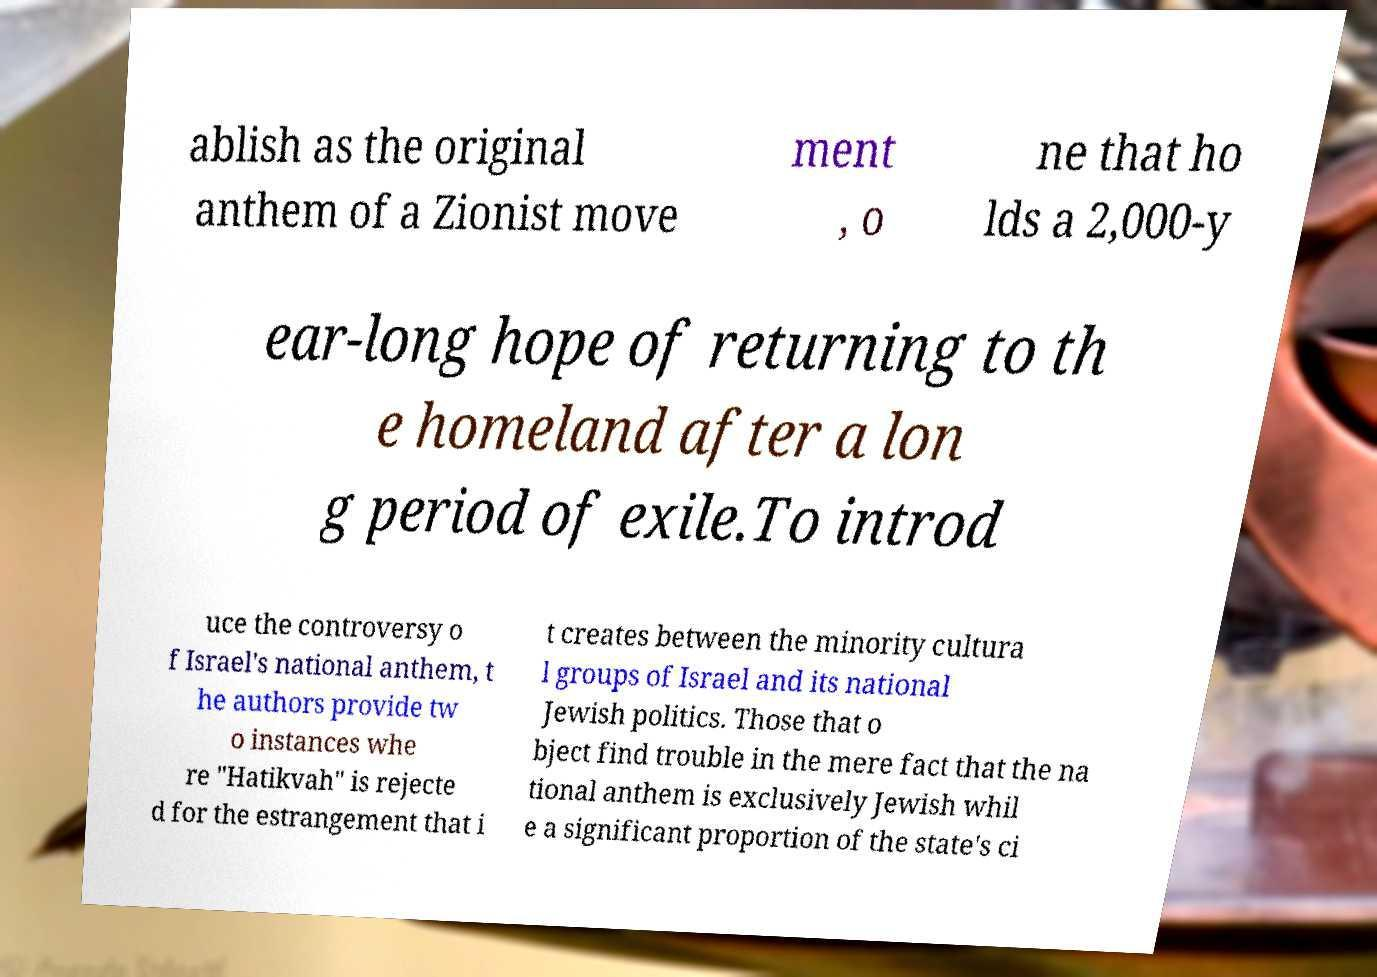What messages or text are displayed in this image? I need them in a readable, typed format. ablish as the original anthem of a Zionist move ment , o ne that ho lds a 2,000-y ear-long hope of returning to th e homeland after a lon g period of exile.To introd uce the controversy o f Israel's national anthem, t he authors provide tw o instances whe re "Hatikvah" is rejecte d for the estrangement that i t creates between the minority cultura l groups of Israel and its national Jewish politics. Those that o bject find trouble in the mere fact that the na tional anthem is exclusively Jewish whil e a significant proportion of the state's ci 